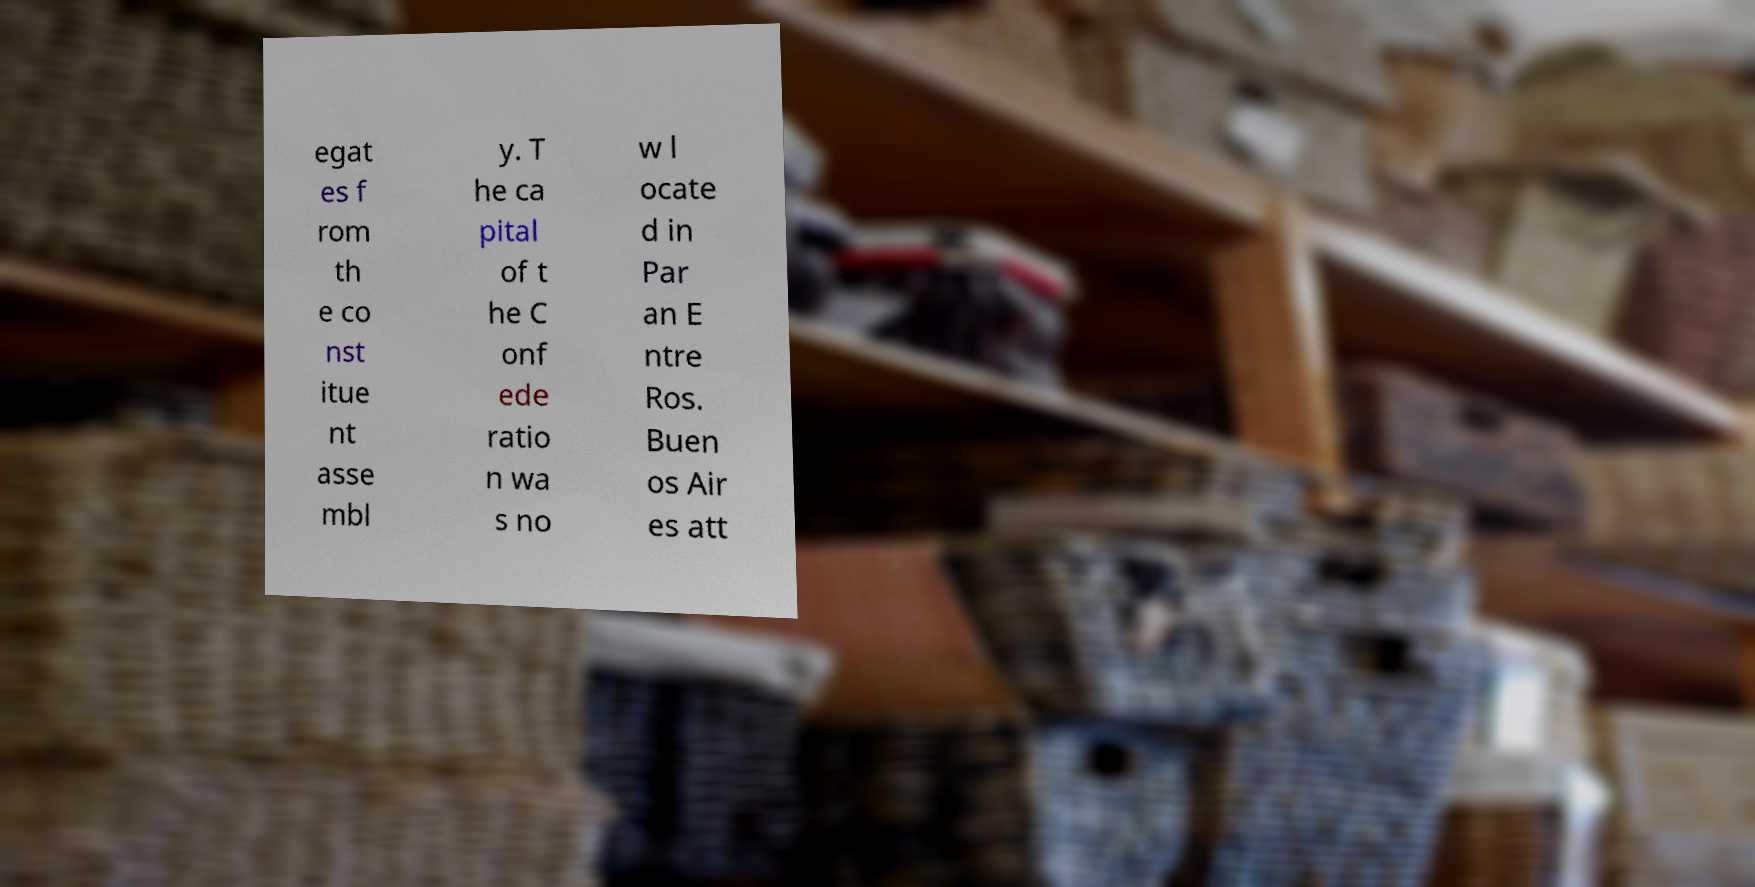Please read and relay the text visible in this image. What does it say? egat es f rom th e co nst itue nt asse mbl y. T he ca pital of t he C onf ede ratio n wa s no w l ocate d in Par an E ntre Ros. Buen os Air es att 